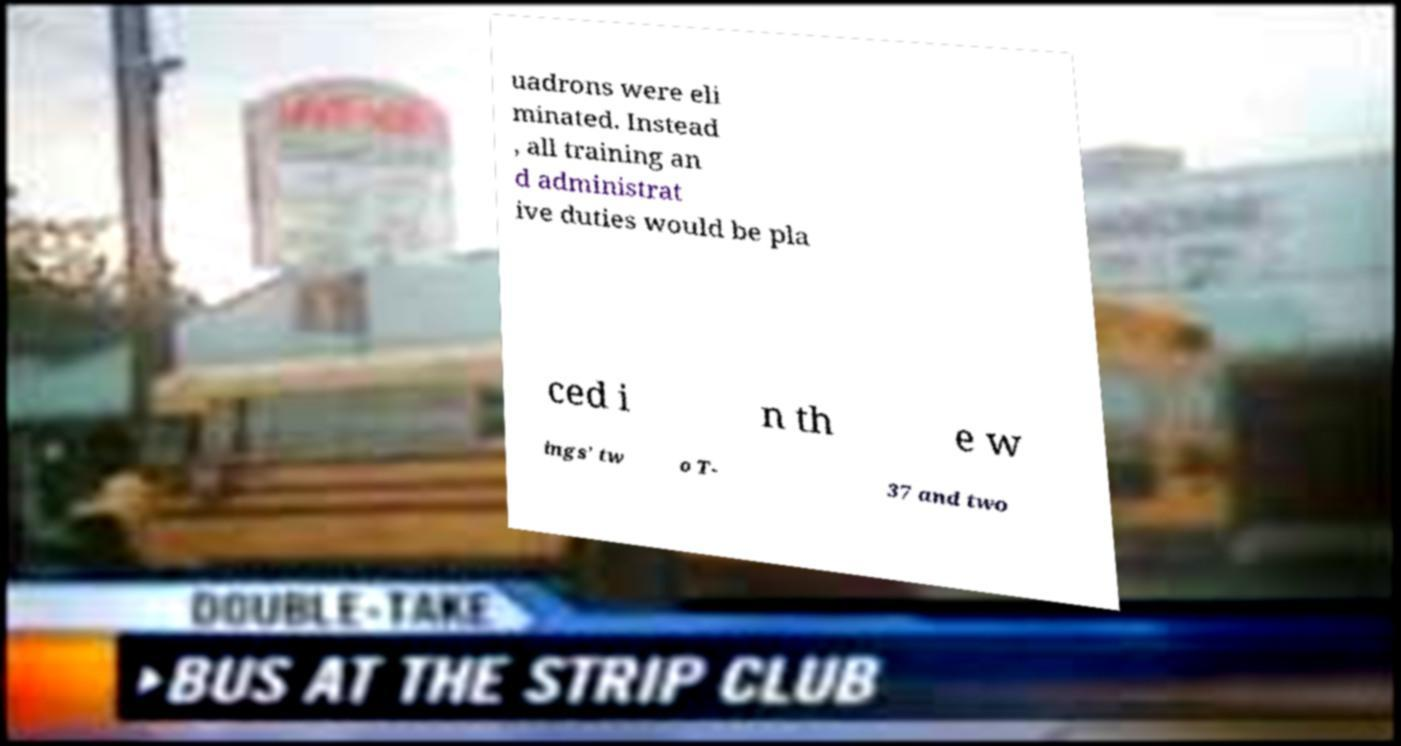For documentation purposes, I need the text within this image transcribed. Could you provide that? uadrons were eli minated. Instead , all training an d administrat ive duties would be pla ced i n th e w ings' tw o T- 37 and two 